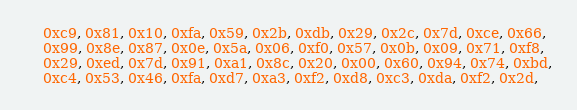<code> <loc_0><loc_0><loc_500><loc_500><_C_>	0xc9, 0x81, 0x10, 0xfa, 0x59, 0x2b, 0xdb, 0x29, 0x2c, 0x7d, 0xce, 0x66,
	0x99, 0x8e, 0x87, 0x0e, 0x5a, 0x06, 0xf0, 0x57, 0x0b, 0x09, 0x71, 0xf8,
	0x29, 0xed, 0x7d, 0x91, 0xa1, 0x8c, 0x20, 0x00, 0x60, 0x94, 0x74, 0xbd,
	0xc4, 0x53, 0x46, 0xfa, 0xd7, 0xa3, 0xf2, 0xd8, 0xc3, 0xda, 0xf2, 0x2d,</code> 